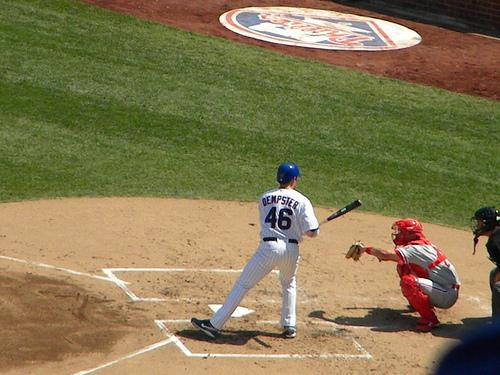What is number 46 waiting for?

Choices:
A) some rest
B) ball pitched
C) lunch
D) time off ball pitched 